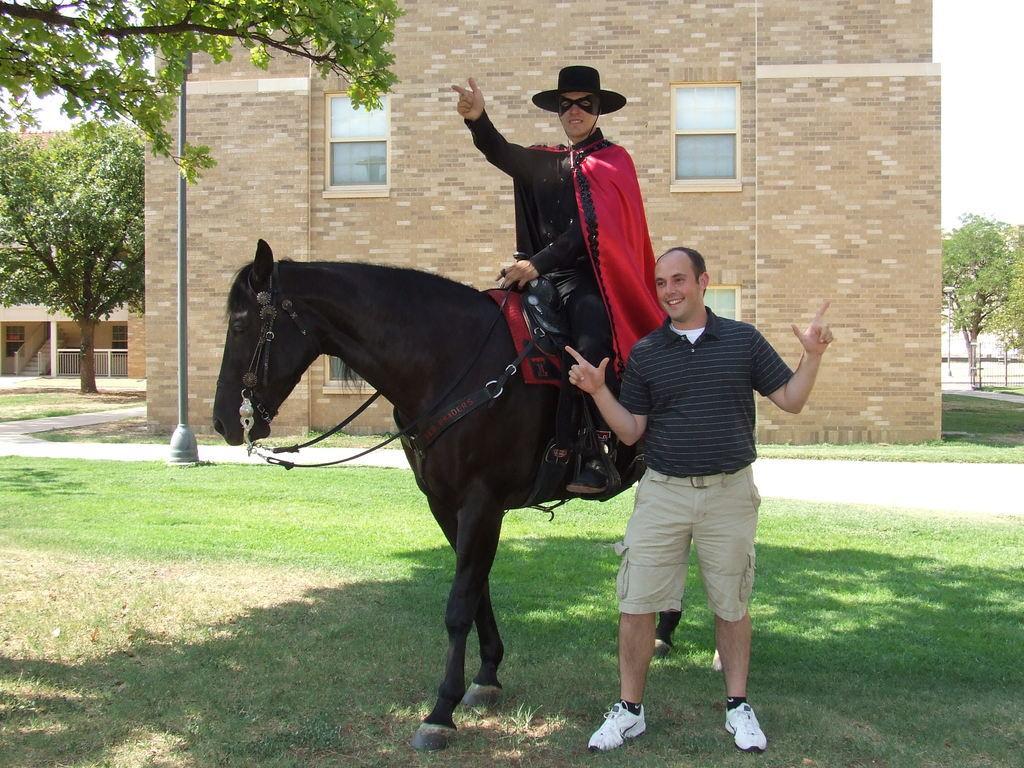Can you describe this image briefly? A man is standing and posing. There is another man sitting on a horse wearing a costume. 